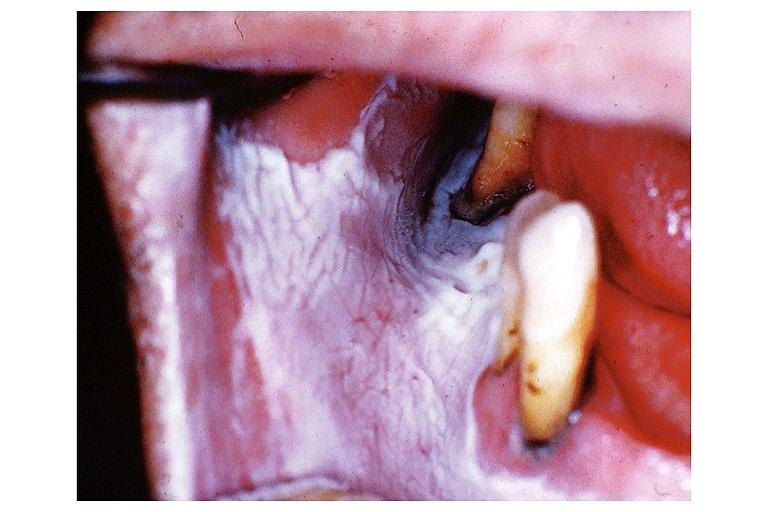s oral present?
Answer the question using a single word or phrase. Yes 